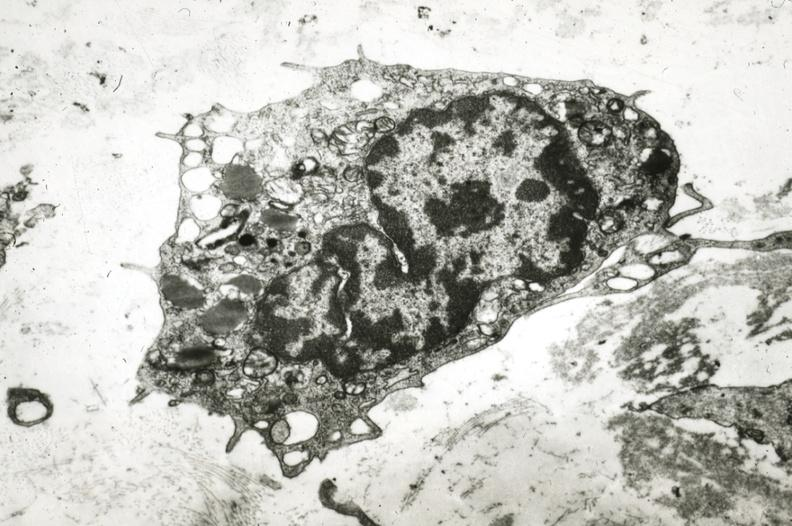what is present?
Answer the question using a single word or phrase. Coronary artery 